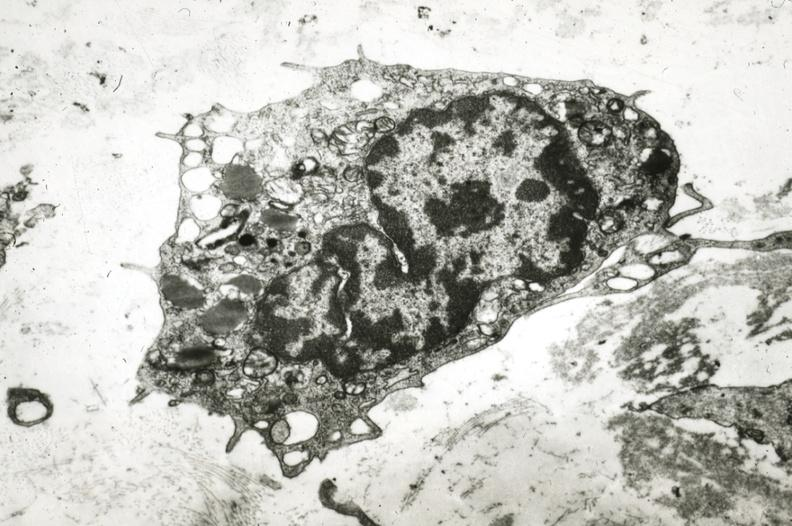what is present?
Answer the question using a single word or phrase. Coronary artery 